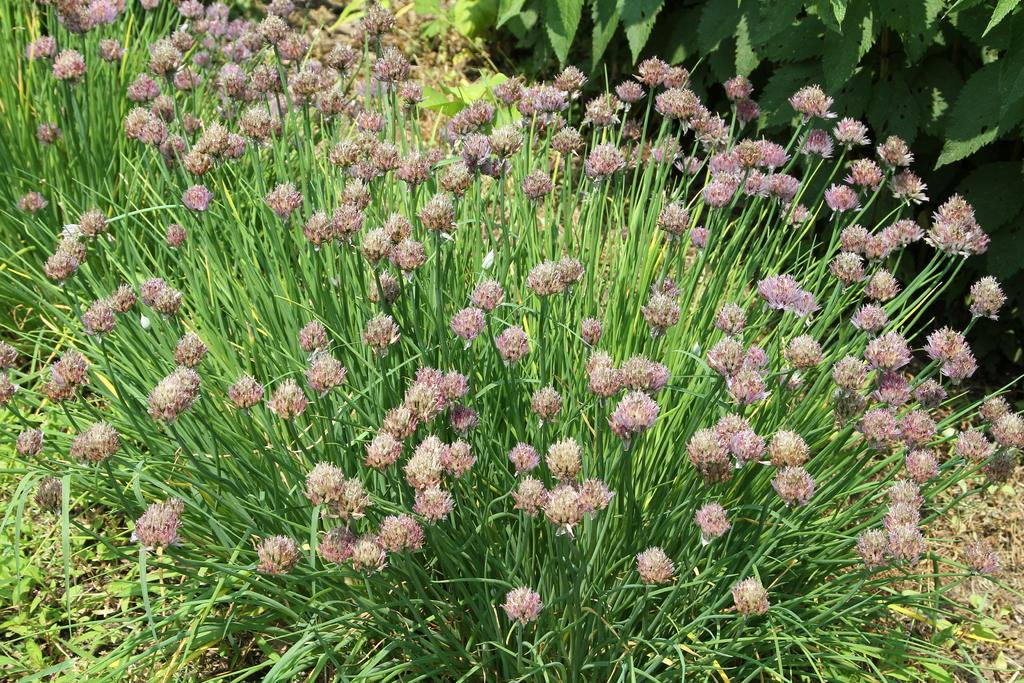What type of living organisms can be seen in the image? Plants can be seen in the image. What specific feature of the plants is visible in the image? The plants have flowers. What type of fuel is being used by the plants in the image? There is no indication in the image that the plants are using any type of fuel, as plants produce their own energy through photosynthesis. 